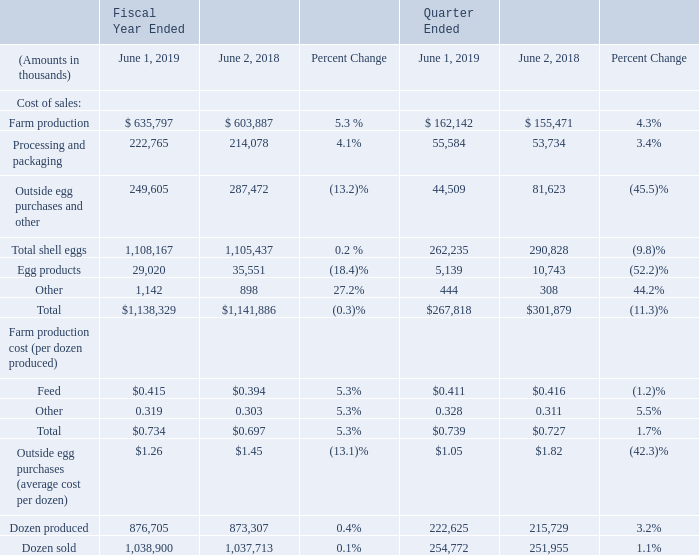COST OF SALES
Cost of sales consists of costs directly related to producing, processing and packing shell eggs, purchases of shell eggs
from outside producers, processing and packing of liquid and frozen egg products and other non-egg costs. Farm
production costs are those costs incurred at the egg production facility, including feed, facility, hen amortization, and
other related farm production costs. The following table presents the key variables affecting our cost of sales:
Cost of sales for the fiscal year ended June 1, 2019 was $1,138.3 million, a decrease of $3.6 million, or 0.3%, compared to $1,141.9 million for fiscal 2018. Comparing fiscal 2019 to fiscal 2018, average cost per dozen purchased from outside shell egg producers decreased while cost of feed ingredients and dozens produced increased. For the 2019 fiscal year we produced 84.4% of the eggs sold by us, as compared to 84.2% for the previous year. Feed cost for fiscal 2019 was $0.415 per dozen, compared to $0.394 per dozen for the prior fiscal year, an increase of 5.3%. The increase in feed costs was primarily related to less favorable crop conditions in the south central U. S., which resulted in higher ingredient prices at some of our larger feed mill operations. The increase in feed cost per dozen resulted in an increase in cost of sales of $18.4 million for fiscal 2019 compared with fiscal 2018.
For the thirteen weeks ended June 1, 2019, compared to the thirteen weeks ended June 2, 2018, cost of sales decreased $34.1 million, or 11.3%, from $301.9 million in the fourth quarter of fiscal 2018, to $267.8 million in the fourth quarter of fiscal 2019. Average cost per dozen purchased from outside shell egg producers decreased 42.3% due to significantly lower egg selling prices in the quarter. Feed cost per dozen for the fourth quarter of fiscal 2019 was $0.411, compared to $0.416 for the same quarter of fiscal 2018, a decrease of 1.2%.
Gross profit, as a percentage of net sales, was 16.4% for fiscal 2019, compared to 24.0% for fiscal 2018. The decrease resulted primarily from lower selling prices for non-specialty eggs.
What is the farm production cost in year ended 2019 as a percentage of total cost?
Answer scale should be: percent. 635,797 / 1,138,329
Answer: 55.85. What was the reason for increase in feed costs in 2019? Increase in feed costs was primarily related to less favorable crop conditions in the south central u. s., which resulted in higher ingredient prices at some of our larger feed mill operations. What was the rationale of decrease in average cost per dozen purchased from outside shell egg producers? Due to significantly lower egg selling prices in the quarter. What was the increase / (decrease) in dozen produced in 2019 compared to 2018?  0.4%. What percentage of total cost does Egg products form a part of in 2019?
Answer scale should be: percent. 29,020 / $1,138,329
Answer: 2.55. What is the cost of sales per dozen produced in year ended 2019?
Answer scale should be: thousand. 1,138,329 / 876,705
Answer: 1.3. 